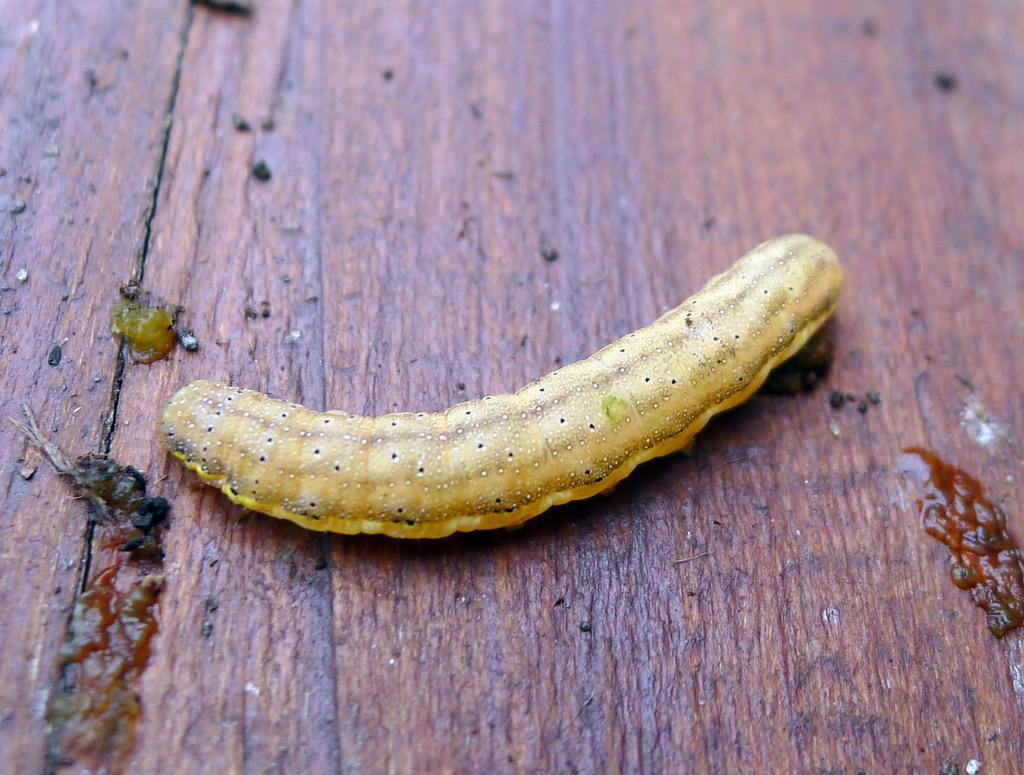What is the main subject of the picture? The main subject of the picture is a caterpillar. Where is the caterpillar located? The caterpillar is on a wooden table. What type of stocking is the caterpillar wearing in the image? There is no stocking present in the image, as the caterpillar is not wearing any clothing. 